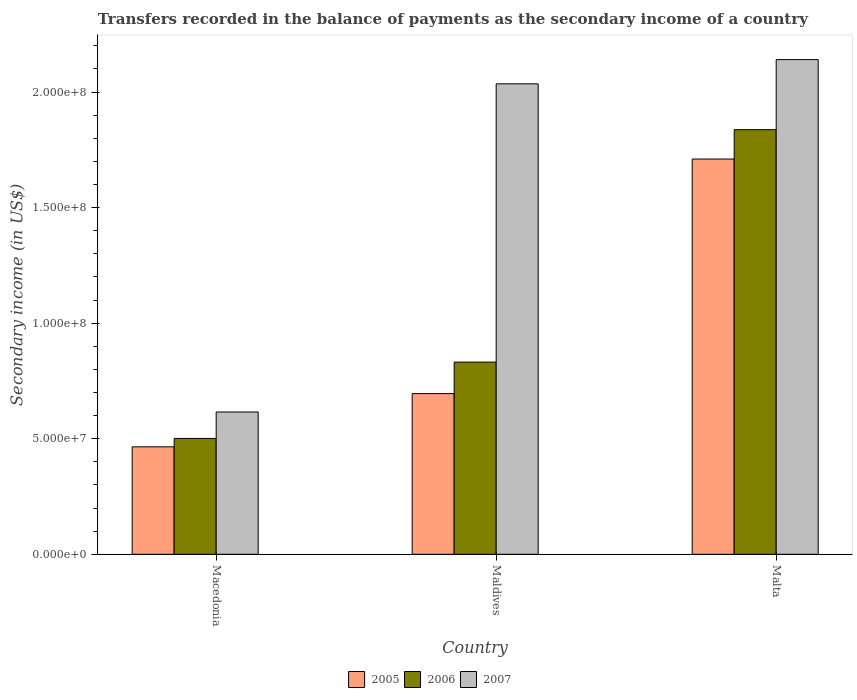How many different coloured bars are there?
Your answer should be very brief. 3. How many groups of bars are there?
Keep it short and to the point. 3. Are the number of bars per tick equal to the number of legend labels?
Provide a short and direct response. Yes. Are the number of bars on each tick of the X-axis equal?
Your response must be concise. Yes. How many bars are there on the 1st tick from the right?
Your answer should be very brief. 3. What is the label of the 3rd group of bars from the left?
Offer a terse response. Malta. What is the secondary income of in 2006 in Maldives?
Provide a short and direct response. 8.32e+07. Across all countries, what is the maximum secondary income of in 2007?
Ensure brevity in your answer.  2.14e+08. Across all countries, what is the minimum secondary income of in 2007?
Provide a short and direct response. 6.16e+07. In which country was the secondary income of in 2005 maximum?
Your answer should be very brief. Malta. In which country was the secondary income of in 2005 minimum?
Keep it short and to the point. Macedonia. What is the total secondary income of in 2005 in the graph?
Make the answer very short. 2.87e+08. What is the difference between the secondary income of in 2007 in Macedonia and that in Maldives?
Make the answer very short. -1.42e+08. What is the difference between the secondary income of in 2005 in Maldives and the secondary income of in 2007 in Macedonia?
Provide a short and direct response. 7.96e+06. What is the average secondary income of in 2006 per country?
Keep it short and to the point. 1.06e+08. What is the difference between the secondary income of of/in 2006 and secondary income of of/in 2007 in Malta?
Your answer should be compact. -3.03e+07. What is the ratio of the secondary income of in 2005 in Maldives to that in Malta?
Make the answer very short. 0.41. Is the secondary income of in 2005 in Maldives less than that in Malta?
Your answer should be compact. Yes. Is the difference between the secondary income of in 2006 in Maldives and Malta greater than the difference between the secondary income of in 2007 in Maldives and Malta?
Offer a terse response. No. What is the difference between the highest and the second highest secondary income of in 2007?
Ensure brevity in your answer.  1.05e+07. What is the difference between the highest and the lowest secondary income of in 2006?
Make the answer very short. 1.34e+08. What does the 1st bar from the right in Macedonia represents?
Provide a short and direct response. 2007. Is it the case that in every country, the sum of the secondary income of in 2006 and secondary income of in 2007 is greater than the secondary income of in 2005?
Your answer should be compact. Yes. How many bars are there?
Make the answer very short. 9. Are all the bars in the graph horizontal?
Ensure brevity in your answer.  No. Are the values on the major ticks of Y-axis written in scientific E-notation?
Give a very brief answer. Yes. Does the graph contain grids?
Give a very brief answer. No. How many legend labels are there?
Provide a succinct answer. 3. What is the title of the graph?
Give a very brief answer. Transfers recorded in the balance of payments as the secondary income of a country. Does "1972" appear as one of the legend labels in the graph?
Your answer should be compact. No. What is the label or title of the X-axis?
Keep it short and to the point. Country. What is the label or title of the Y-axis?
Give a very brief answer. Secondary income (in US$). What is the Secondary income (in US$) in 2005 in Macedonia?
Provide a succinct answer. 4.65e+07. What is the Secondary income (in US$) in 2006 in Macedonia?
Make the answer very short. 5.01e+07. What is the Secondary income (in US$) of 2007 in Macedonia?
Make the answer very short. 6.16e+07. What is the Secondary income (in US$) in 2005 in Maldives?
Your answer should be very brief. 6.95e+07. What is the Secondary income (in US$) in 2006 in Maldives?
Provide a succinct answer. 8.32e+07. What is the Secondary income (in US$) in 2007 in Maldives?
Your answer should be very brief. 2.04e+08. What is the Secondary income (in US$) in 2005 in Malta?
Keep it short and to the point. 1.71e+08. What is the Secondary income (in US$) of 2006 in Malta?
Make the answer very short. 1.84e+08. What is the Secondary income (in US$) of 2007 in Malta?
Make the answer very short. 2.14e+08. Across all countries, what is the maximum Secondary income (in US$) of 2005?
Keep it short and to the point. 1.71e+08. Across all countries, what is the maximum Secondary income (in US$) in 2006?
Keep it short and to the point. 1.84e+08. Across all countries, what is the maximum Secondary income (in US$) of 2007?
Keep it short and to the point. 2.14e+08. Across all countries, what is the minimum Secondary income (in US$) of 2005?
Make the answer very short. 4.65e+07. Across all countries, what is the minimum Secondary income (in US$) of 2006?
Your answer should be very brief. 5.01e+07. Across all countries, what is the minimum Secondary income (in US$) in 2007?
Ensure brevity in your answer.  6.16e+07. What is the total Secondary income (in US$) of 2005 in the graph?
Keep it short and to the point. 2.87e+08. What is the total Secondary income (in US$) of 2006 in the graph?
Give a very brief answer. 3.17e+08. What is the total Secondary income (in US$) of 2007 in the graph?
Your answer should be very brief. 4.79e+08. What is the difference between the Secondary income (in US$) in 2005 in Macedonia and that in Maldives?
Make the answer very short. -2.30e+07. What is the difference between the Secondary income (in US$) in 2006 in Macedonia and that in Maldives?
Offer a terse response. -3.30e+07. What is the difference between the Secondary income (in US$) of 2007 in Macedonia and that in Maldives?
Offer a very short reply. -1.42e+08. What is the difference between the Secondary income (in US$) in 2005 in Macedonia and that in Malta?
Keep it short and to the point. -1.25e+08. What is the difference between the Secondary income (in US$) in 2006 in Macedonia and that in Malta?
Keep it short and to the point. -1.34e+08. What is the difference between the Secondary income (in US$) of 2007 in Macedonia and that in Malta?
Give a very brief answer. -1.52e+08. What is the difference between the Secondary income (in US$) in 2005 in Maldives and that in Malta?
Provide a short and direct response. -1.01e+08. What is the difference between the Secondary income (in US$) of 2006 in Maldives and that in Malta?
Make the answer very short. -1.01e+08. What is the difference between the Secondary income (in US$) of 2007 in Maldives and that in Malta?
Offer a terse response. -1.05e+07. What is the difference between the Secondary income (in US$) of 2005 in Macedonia and the Secondary income (in US$) of 2006 in Maldives?
Your answer should be compact. -3.67e+07. What is the difference between the Secondary income (in US$) of 2005 in Macedonia and the Secondary income (in US$) of 2007 in Maldives?
Provide a succinct answer. -1.57e+08. What is the difference between the Secondary income (in US$) of 2006 in Macedonia and the Secondary income (in US$) of 2007 in Maldives?
Your answer should be compact. -1.53e+08. What is the difference between the Secondary income (in US$) in 2005 in Macedonia and the Secondary income (in US$) in 2006 in Malta?
Provide a succinct answer. -1.37e+08. What is the difference between the Secondary income (in US$) in 2005 in Macedonia and the Secondary income (in US$) in 2007 in Malta?
Give a very brief answer. -1.68e+08. What is the difference between the Secondary income (in US$) of 2006 in Macedonia and the Secondary income (in US$) of 2007 in Malta?
Ensure brevity in your answer.  -1.64e+08. What is the difference between the Secondary income (in US$) in 2005 in Maldives and the Secondary income (in US$) in 2006 in Malta?
Ensure brevity in your answer.  -1.14e+08. What is the difference between the Secondary income (in US$) in 2005 in Maldives and the Secondary income (in US$) in 2007 in Malta?
Make the answer very short. -1.45e+08. What is the difference between the Secondary income (in US$) in 2006 in Maldives and the Secondary income (in US$) in 2007 in Malta?
Your answer should be compact. -1.31e+08. What is the average Secondary income (in US$) of 2005 per country?
Keep it short and to the point. 9.57e+07. What is the average Secondary income (in US$) in 2006 per country?
Offer a very short reply. 1.06e+08. What is the average Secondary income (in US$) in 2007 per country?
Provide a short and direct response. 1.60e+08. What is the difference between the Secondary income (in US$) of 2005 and Secondary income (in US$) of 2006 in Macedonia?
Provide a short and direct response. -3.63e+06. What is the difference between the Secondary income (in US$) of 2005 and Secondary income (in US$) of 2007 in Macedonia?
Make the answer very short. -1.51e+07. What is the difference between the Secondary income (in US$) of 2006 and Secondary income (in US$) of 2007 in Macedonia?
Offer a terse response. -1.14e+07. What is the difference between the Secondary income (in US$) of 2005 and Secondary income (in US$) of 2006 in Maldives?
Your answer should be very brief. -1.36e+07. What is the difference between the Secondary income (in US$) of 2005 and Secondary income (in US$) of 2007 in Maldives?
Provide a short and direct response. -1.34e+08. What is the difference between the Secondary income (in US$) of 2006 and Secondary income (in US$) of 2007 in Maldives?
Your answer should be very brief. -1.20e+08. What is the difference between the Secondary income (in US$) of 2005 and Secondary income (in US$) of 2006 in Malta?
Your response must be concise. -1.27e+07. What is the difference between the Secondary income (in US$) in 2005 and Secondary income (in US$) in 2007 in Malta?
Keep it short and to the point. -4.30e+07. What is the difference between the Secondary income (in US$) in 2006 and Secondary income (in US$) in 2007 in Malta?
Keep it short and to the point. -3.03e+07. What is the ratio of the Secondary income (in US$) of 2005 in Macedonia to that in Maldives?
Your answer should be compact. 0.67. What is the ratio of the Secondary income (in US$) in 2006 in Macedonia to that in Maldives?
Ensure brevity in your answer.  0.6. What is the ratio of the Secondary income (in US$) of 2007 in Macedonia to that in Maldives?
Provide a succinct answer. 0.3. What is the ratio of the Secondary income (in US$) in 2005 in Macedonia to that in Malta?
Ensure brevity in your answer.  0.27. What is the ratio of the Secondary income (in US$) of 2006 in Macedonia to that in Malta?
Your answer should be compact. 0.27. What is the ratio of the Secondary income (in US$) of 2007 in Macedonia to that in Malta?
Give a very brief answer. 0.29. What is the ratio of the Secondary income (in US$) in 2005 in Maldives to that in Malta?
Make the answer very short. 0.41. What is the ratio of the Secondary income (in US$) of 2006 in Maldives to that in Malta?
Ensure brevity in your answer.  0.45. What is the ratio of the Secondary income (in US$) of 2007 in Maldives to that in Malta?
Provide a succinct answer. 0.95. What is the difference between the highest and the second highest Secondary income (in US$) in 2005?
Your response must be concise. 1.01e+08. What is the difference between the highest and the second highest Secondary income (in US$) of 2006?
Keep it short and to the point. 1.01e+08. What is the difference between the highest and the second highest Secondary income (in US$) of 2007?
Make the answer very short. 1.05e+07. What is the difference between the highest and the lowest Secondary income (in US$) of 2005?
Provide a succinct answer. 1.25e+08. What is the difference between the highest and the lowest Secondary income (in US$) in 2006?
Give a very brief answer. 1.34e+08. What is the difference between the highest and the lowest Secondary income (in US$) of 2007?
Offer a very short reply. 1.52e+08. 